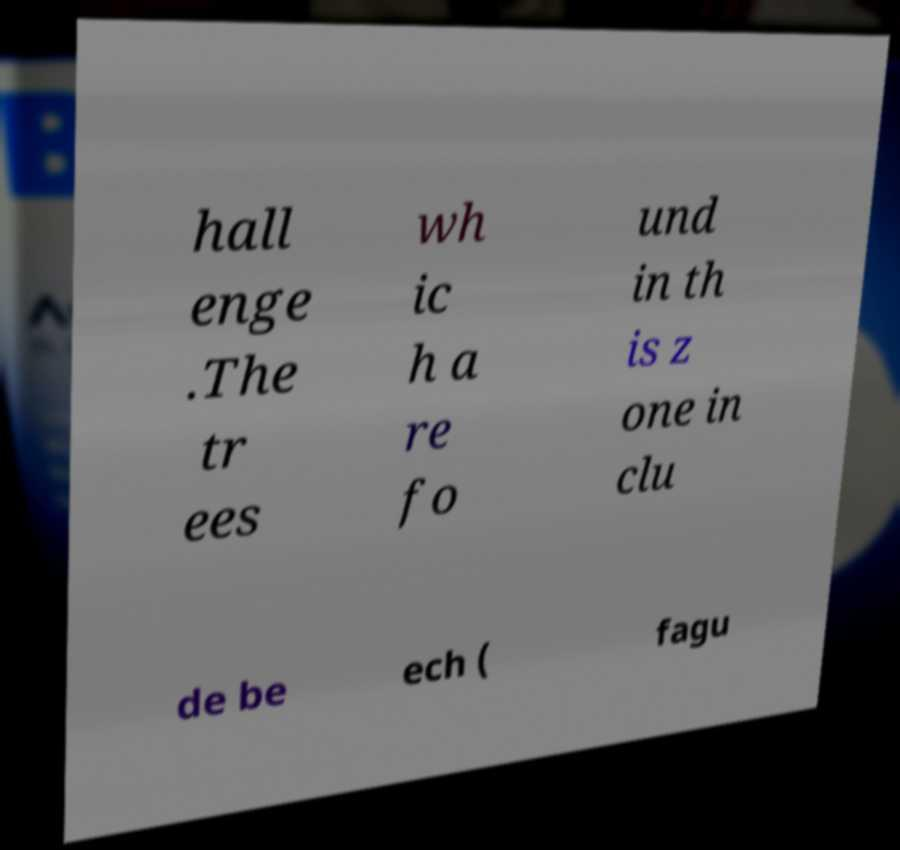I need the written content from this picture converted into text. Can you do that? hall enge .The tr ees wh ic h a re fo und in th is z one in clu de be ech ( fagu 